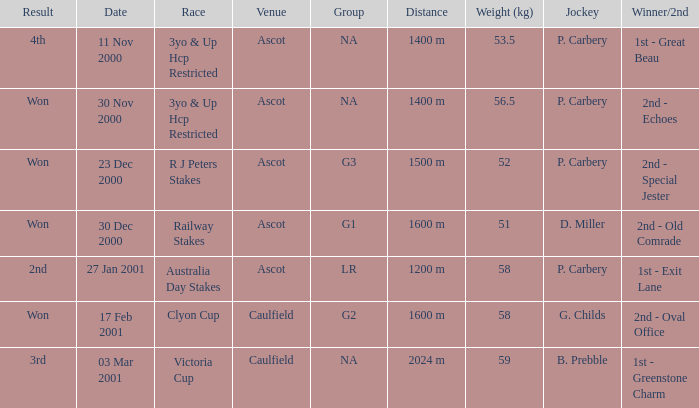What was the outcome of the railway stakes race? Won. 